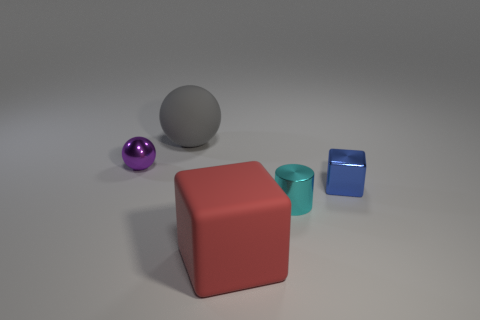Add 1 small metal spheres. How many objects exist? 6 Subtract all spheres. How many objects are left? 3 Add 4 small cyan cylinders. How many small cyan cylinders exist? 5 Subtract 0 purple cylinders. How many objects are left? 5 Subtract all large yellow shiny cubes. Subtract all small blue shiny cubes. How many objects are left? 4 Add 1 red things. How many red things are left? 2 